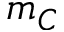<formula> <loc_0><loc_0><loc_500><loc_500>m _ { C }</formula> 